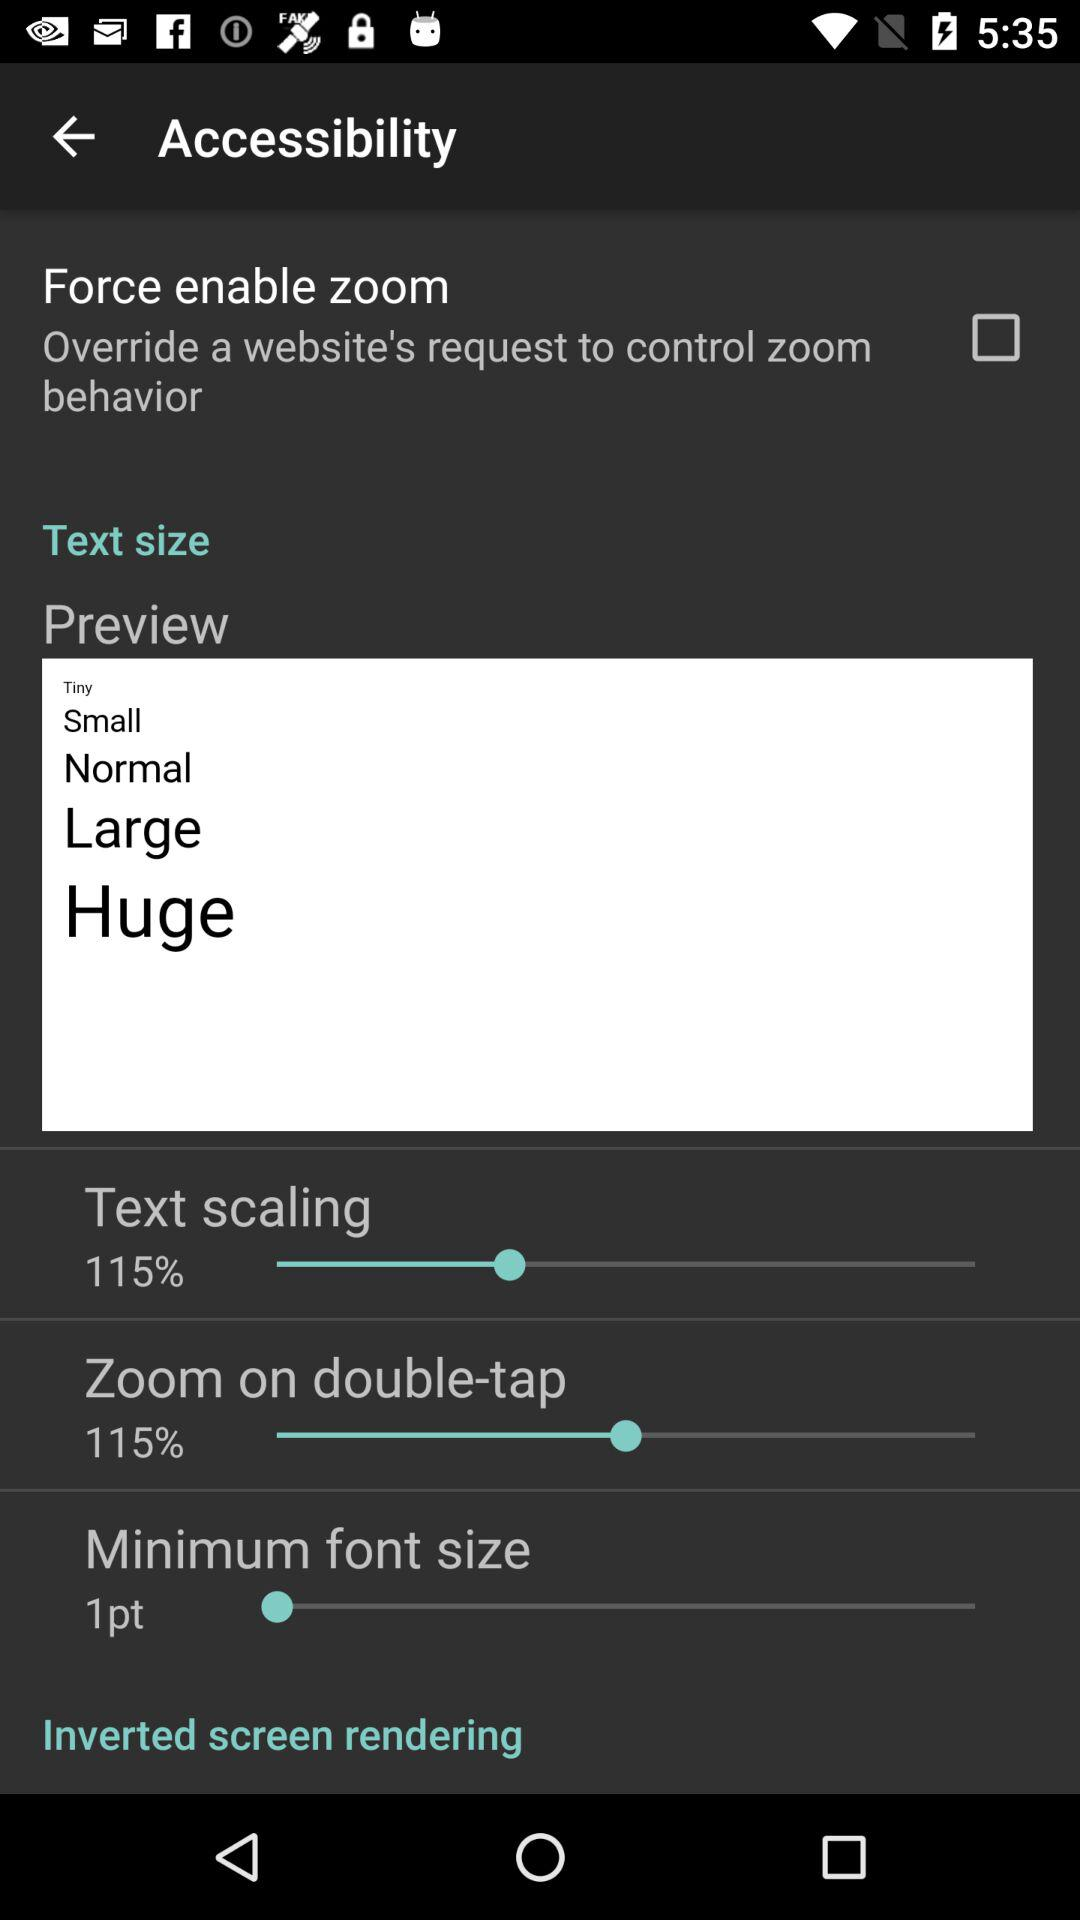What is the percentage of text scaling? The percentage of text scaling is 115. 